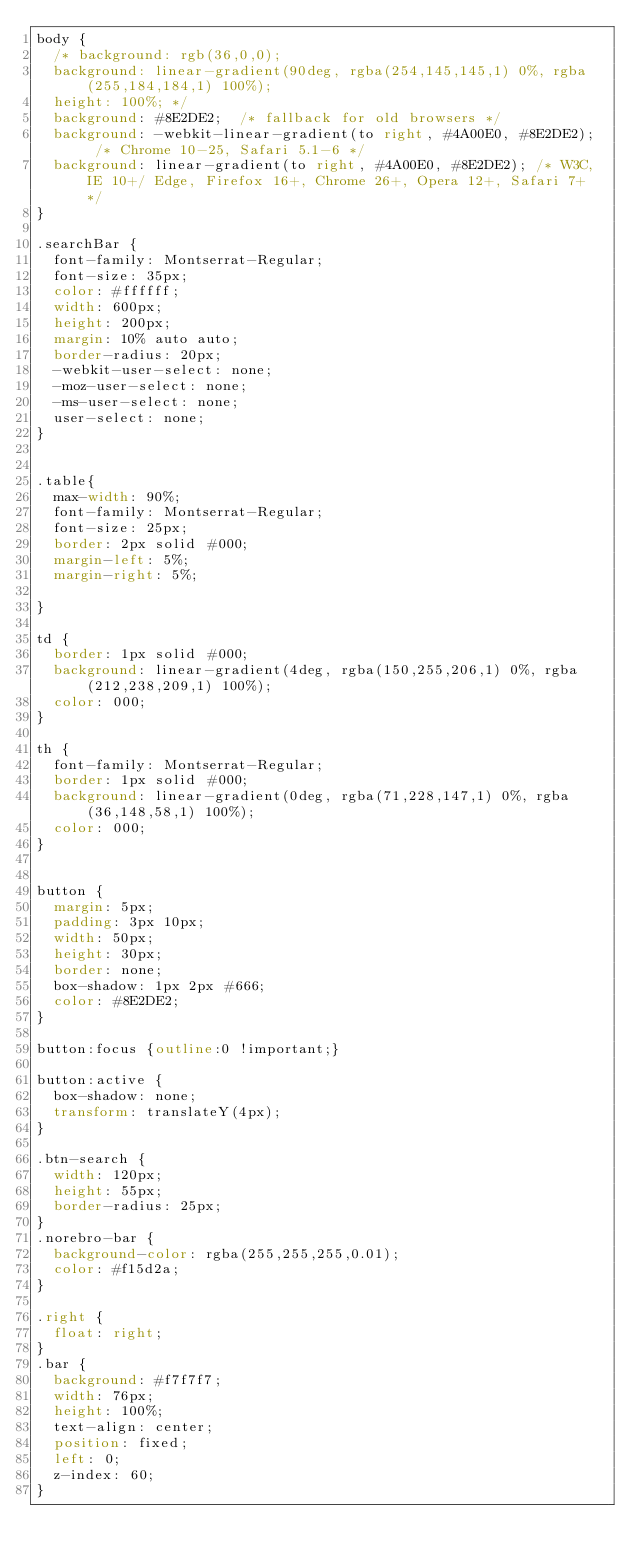<code> <loc_0><loc_0><loc_500><loc_500><_CSS_>body {
  /* background: rgb(36,0,0);
  background: linear-gradient(90deg, rgba(254,145,145,1) 0%, rgba(255,184,184,1) 100%);
  height: 100%; */
  background: #8E2DE2;  /* fallback for old browsers */
  background: -webkit-linear-gradient(to right, #4A00E0, #8E2DE2);  /* Chrome 10-25, Safari 5.1-6 */
  background: linear-gradient(to right, #4A00E0, #8E2DE2); /* W3C, IE 10+/ Edge, Firefox 16+, Chrome 26+, Opera 12+, Safari 7+ */
}

.searchBar {
  font-family: Montserrat-Regular;
  font-size: 35px;
  color: #ffffff;
  width: 600px;
  height: 200px;
  margin: 10% auto auto;
  border-radius: 20px;
  -webkit-user-select: none;
  -moz-user-select: none;
  -ms-user-select: none;
  user-select: none;
}


.table{
  max-width: 90%;
  font-family: Montserrat-Regular;
  font-size: 25px;
  border: 2px solid #000;
  margin-left: 5%;
  margin-right: 5%;

}

td {
  border: 1px solid #000;
  background: linear-gradient(4deg, rgba(150,255,206,1) 0%, rgba(212,238,209,1) 100%);
  color: 000;
}

th {
  font-family: Montserrat-Regular;
  border: 1px solid #000;
  background: linear-gradient(0deg, rgba(71,228,147,1) 0%, rgba(36,148,58,1) 100%);
  color: 000;
}


button {
  margin: 5px;
  padding: 3px 10px;
  width: 50px;
  height: 30px;
  border: none;
  box-shadow: 1px 2px #666;
  color: #8E2DE2;
}

button:focus {outline:0 !important;}

button:active {
  box-shadow: none;
  transform: translateY(4px);
}

.btn-search {
  width: 120px;
  height: 55px;
  border-radius: 25px;
}
.norebro-bar {
  background-color: rgba(255,255,255,0.01);
  color: #f15d2a;
}

.right {
  float: right;
}
.bar {
  background: #f7f7f7;
  width: 76px;
  height: 100%;
  text-align: center;
  position: fixed;
  left: 0;
  z-index: 60;
}</code> 